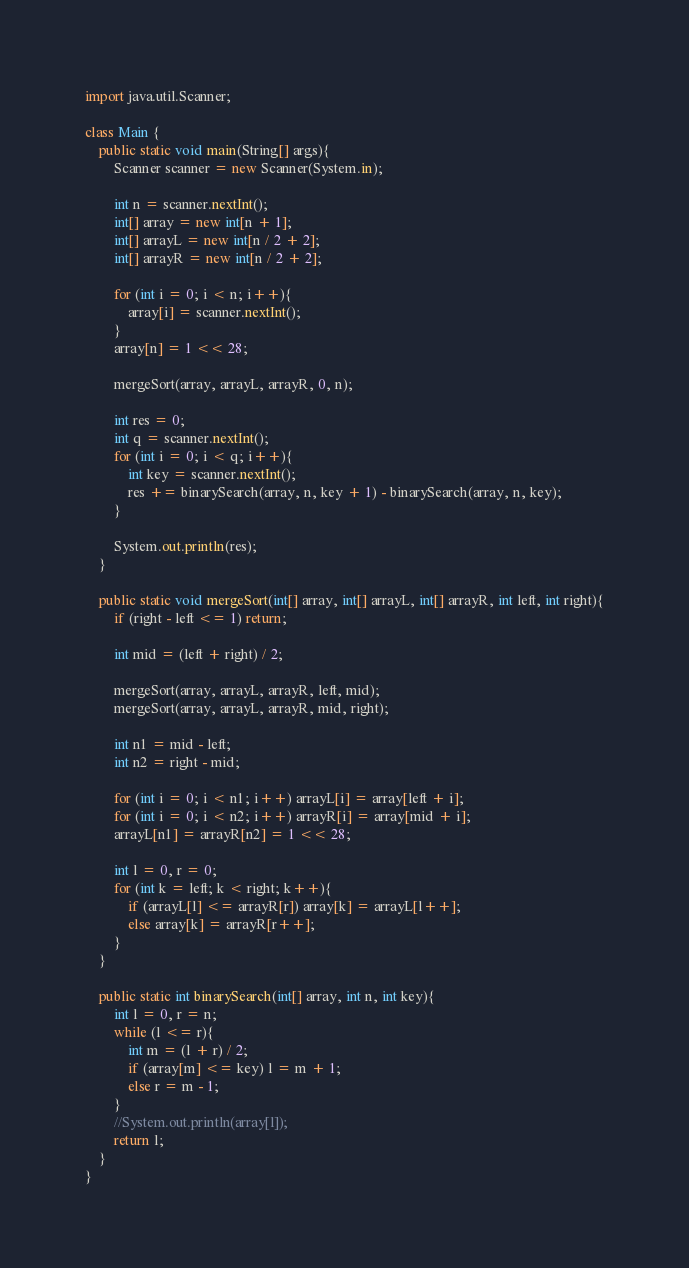Convert code to text. <code><loc_0><loc_0><loc_500><loc_500><_Java_>import java.util.Scanner;

class Main {
	public static void main(String[] args){
		Scanner scanner = new Scanner(System.in);
		
		int n = scanner.nextInt();
		int[] array = new int[n + 1];
		int[] arrayL = new int[n / 2 + 2];
		int[] arrayR = new int[n / 2 + 2];
		
		for (int i = 0; i < n; i++){
			array[i] = scanner.nextInt();
		}
		array[n] = 1 << 28;
		
		mergeSort(array, arrayL, arrayR, 0, n);
		
		int res = 0;
		int q = scanner.nextInt();
		for (int i = 0; i < q; i++){
			int key = scanner.nextInt();
			res += binarySearch(array, n, key + 1) - binarySearch(array, n, key);
		}
		
		System.out.println(res);
	}
	
	public static void mergeSort(int[] array, int[] arrayL, int[] arrayR, int left, int right){
		if (right - left <= 1) return;
		
		int mid = (left + right) / 2;
		
		mergeSort(array, arrayL, arrayR, left, mid);
		mergeSort(array, arrayL, arrayR, mid, right);
		
		int n1 = mid - left;
		int n2 = right - mid;
		
		for (int i = 0; i < n1; i++) arrayL[i] = array[left + i];
		for (int i = 0; i < n2; i++) arrayR[i] = array[mid + i];
		arrayL[n1] = arrayR[n2] = 1 << 28;
		
		int l = 0, r = 0;
		for (int k = left; k < right; k++){
			if (arrayL[l] <= arrayR[r]) array[k] = arrayL[l++];
			else array[k] = arrayR[r++];
		}
	}
	
	public static int binarySearch(int[] array, int n, int key){
		int l = 0, r = n;
		while (l <= r){
			int m = (l + r) / 2;
			if (array[m] <= key) l = m + 1;
			else r = m - 1;
		}
		//System.out.println(array[l]);
		return l;
	}
}</code> 